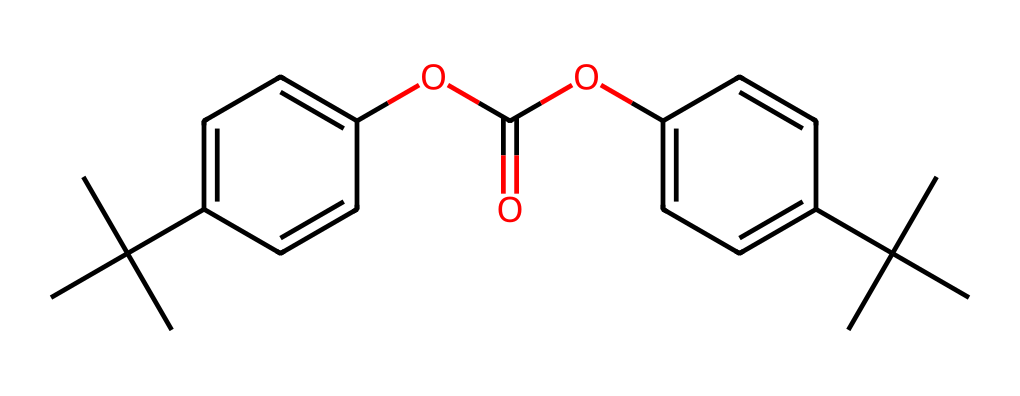How many carbon atoms are present in this chemical structure? To determine the number of carbon atoms, count each 'C' in the SMILES representation. The branched structures and rings also denote carbon atoms. By carefully analyzing the structure, we find there are 21 carbon atoms in total.
Answer: 21 What type of functional group is present in this compound? The chemical contains an ester functional group, which can be identified by the presence of the -OC(=O)- segment that connects two aromatic rings, indicating an ester bond is formed between them.
Answer: ester What is the molecular weight of this polycarbonate compound? To calculate the molecular weight, we sum the atomic weights of all the atoms present in the chemical. With 21 carbon, 30 hydrogen, and 4 oxygen, we calculate: (21×12.01) + (30×1.008) + (4×16.00) = 330.34 g/mol. Thus, the molecular weight is around 330.34 g/mol.
Answer: 330.34 Does this compound contain any heteroatoms? By examining the SMILES string, we identify the presence of oxygen atoms ('O'), which classifies them as heteroatoms. Since these are not carbon or hydrogen, they qualify as heteroatoms.
Answer: yes What characteristic properties can be derived from the presence of bulky substituents in this chemical? The bulky substituents, such as the tert-butyl groups, influence the physical properties such as rigidity and light transmission. Their presence discourages close packing of molecules, leading to lower density and enhanced impact resistance.
Answer: rigidity Is this compound soluble in water? As a polycarbonate with a significant non-polar hydrocarbon content and a bulky structure, it is expected to have low water solubility. Polycarbonates generally demonstrate poor solubility in water due to their non-polar nature.
Answer: no 